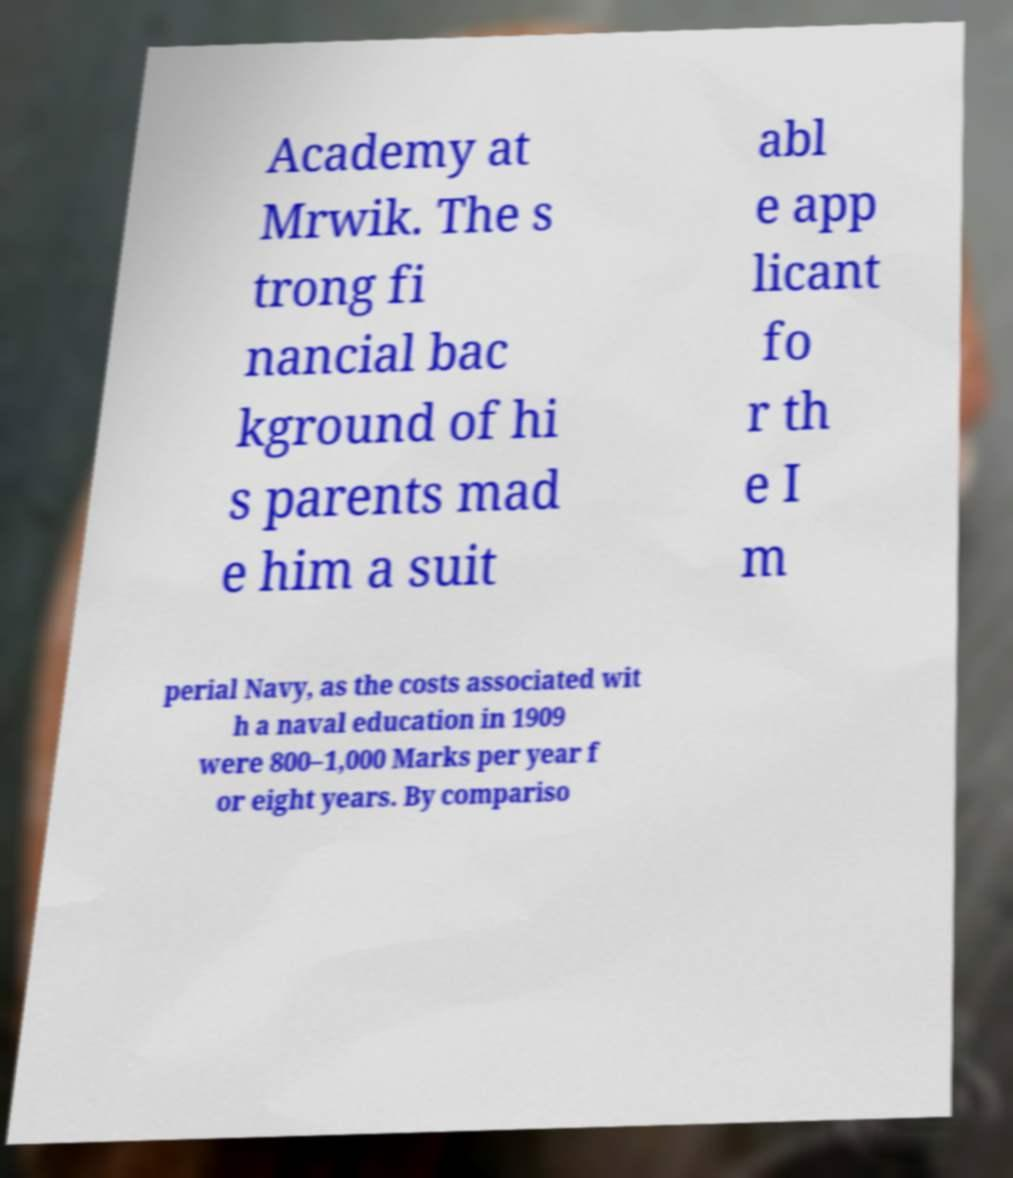For documentation purposes, I need the text within this image transcribed. Could you provide that? Academy at Mrwik. The s trong fi nancial bac kground of hi s parents mad e him a suit abl e app licant fo r th e I m perial Navy, as the costs associated wit h a naval education in 1909 were 800–1,000 Marks per year f or eight years. By compariso 